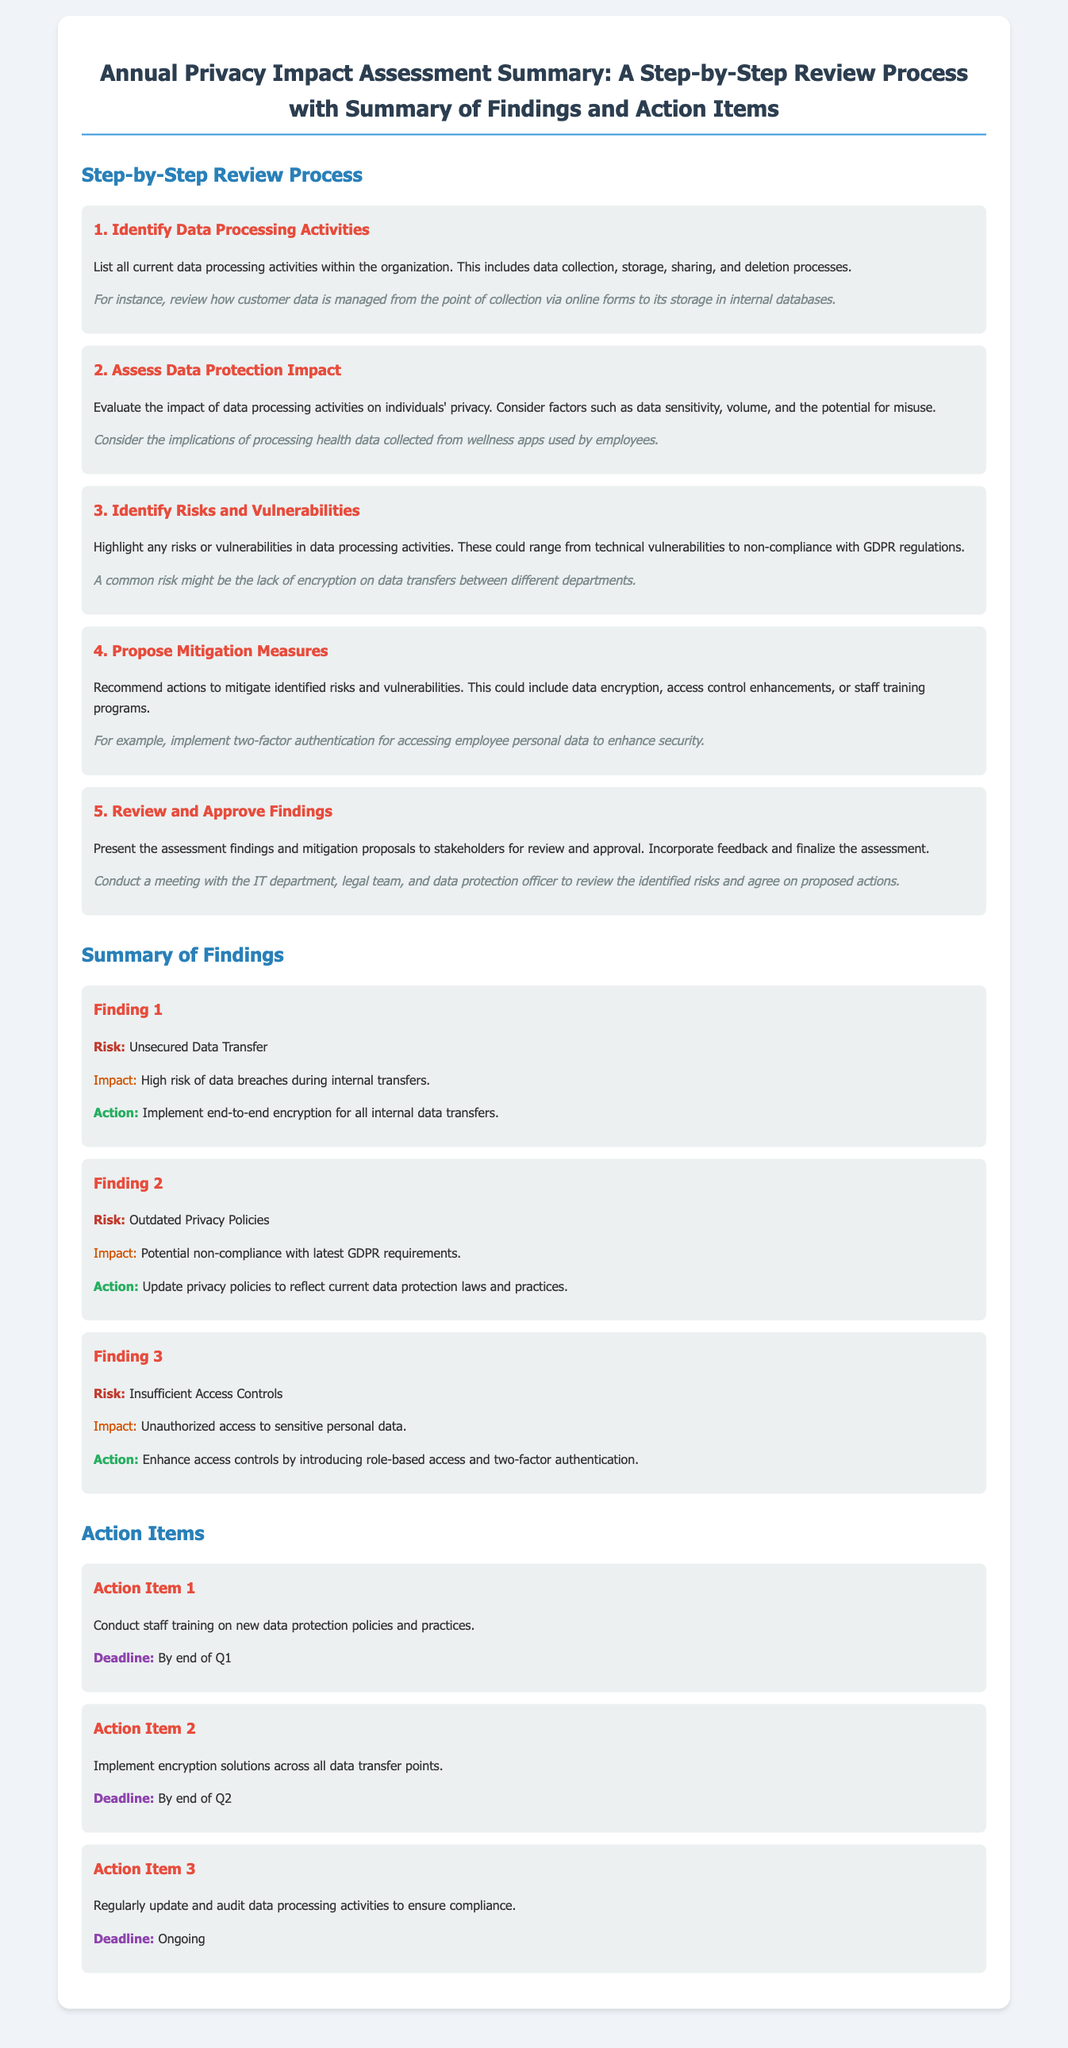what is the title of the document? The title is found at the top of the document and summarizes its content.
Answer: Annual Privacy Impact Assessment Summary: A Step-by-Step Review Process with Summary of Findings and Action Items how many steps are in the review process? The number of steps is specified in the section on the review process.
Answer: 5 what is Finding 2 about? Finding 2 addresses a specific issue identified during the privacy impact assessment.
Answer: Outdated Privacy Policies what is the deadline for Action Item 1? The deadline for Action Item 1 is mentioned explicitly in the corresponding action item section.
Answer: By end of Q1 what is the impact of Finding 1? The impact of Finding 1 is described following the risk mentioned.
Answer: High risk of data breaches during internal transfers what mitigation measure is proposed for Finding 3? The proposed action for Finding 3 is included in the findings section.
Answer: Enhance access controls by introducing role-based access and two-factor authentication what should be conducted as Action Item 2? Action Item 2 specifies a required action to enhance data protection measures.
Answer: Implement encryption solutions across all data transfer points what type of document is this? This question asks for the classification of the document based on its structure and content.
Answer: Recipe card what is the risk associated with Finding 3? The risk related to Finding 3 is listed in the summary of findings section.
Answer: Insufficient Access Controls 